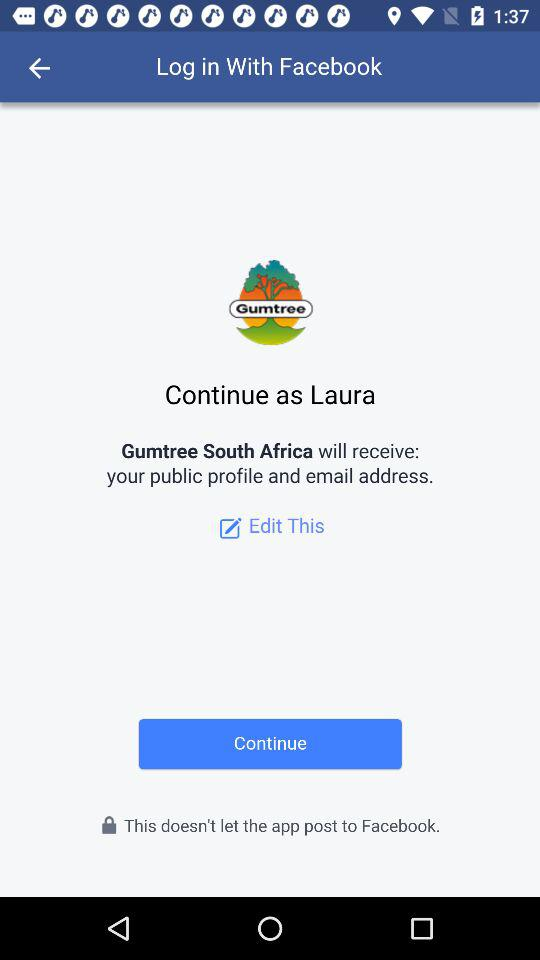What application will receive my public profile and email address? The application is "Gumtree South Africa". 